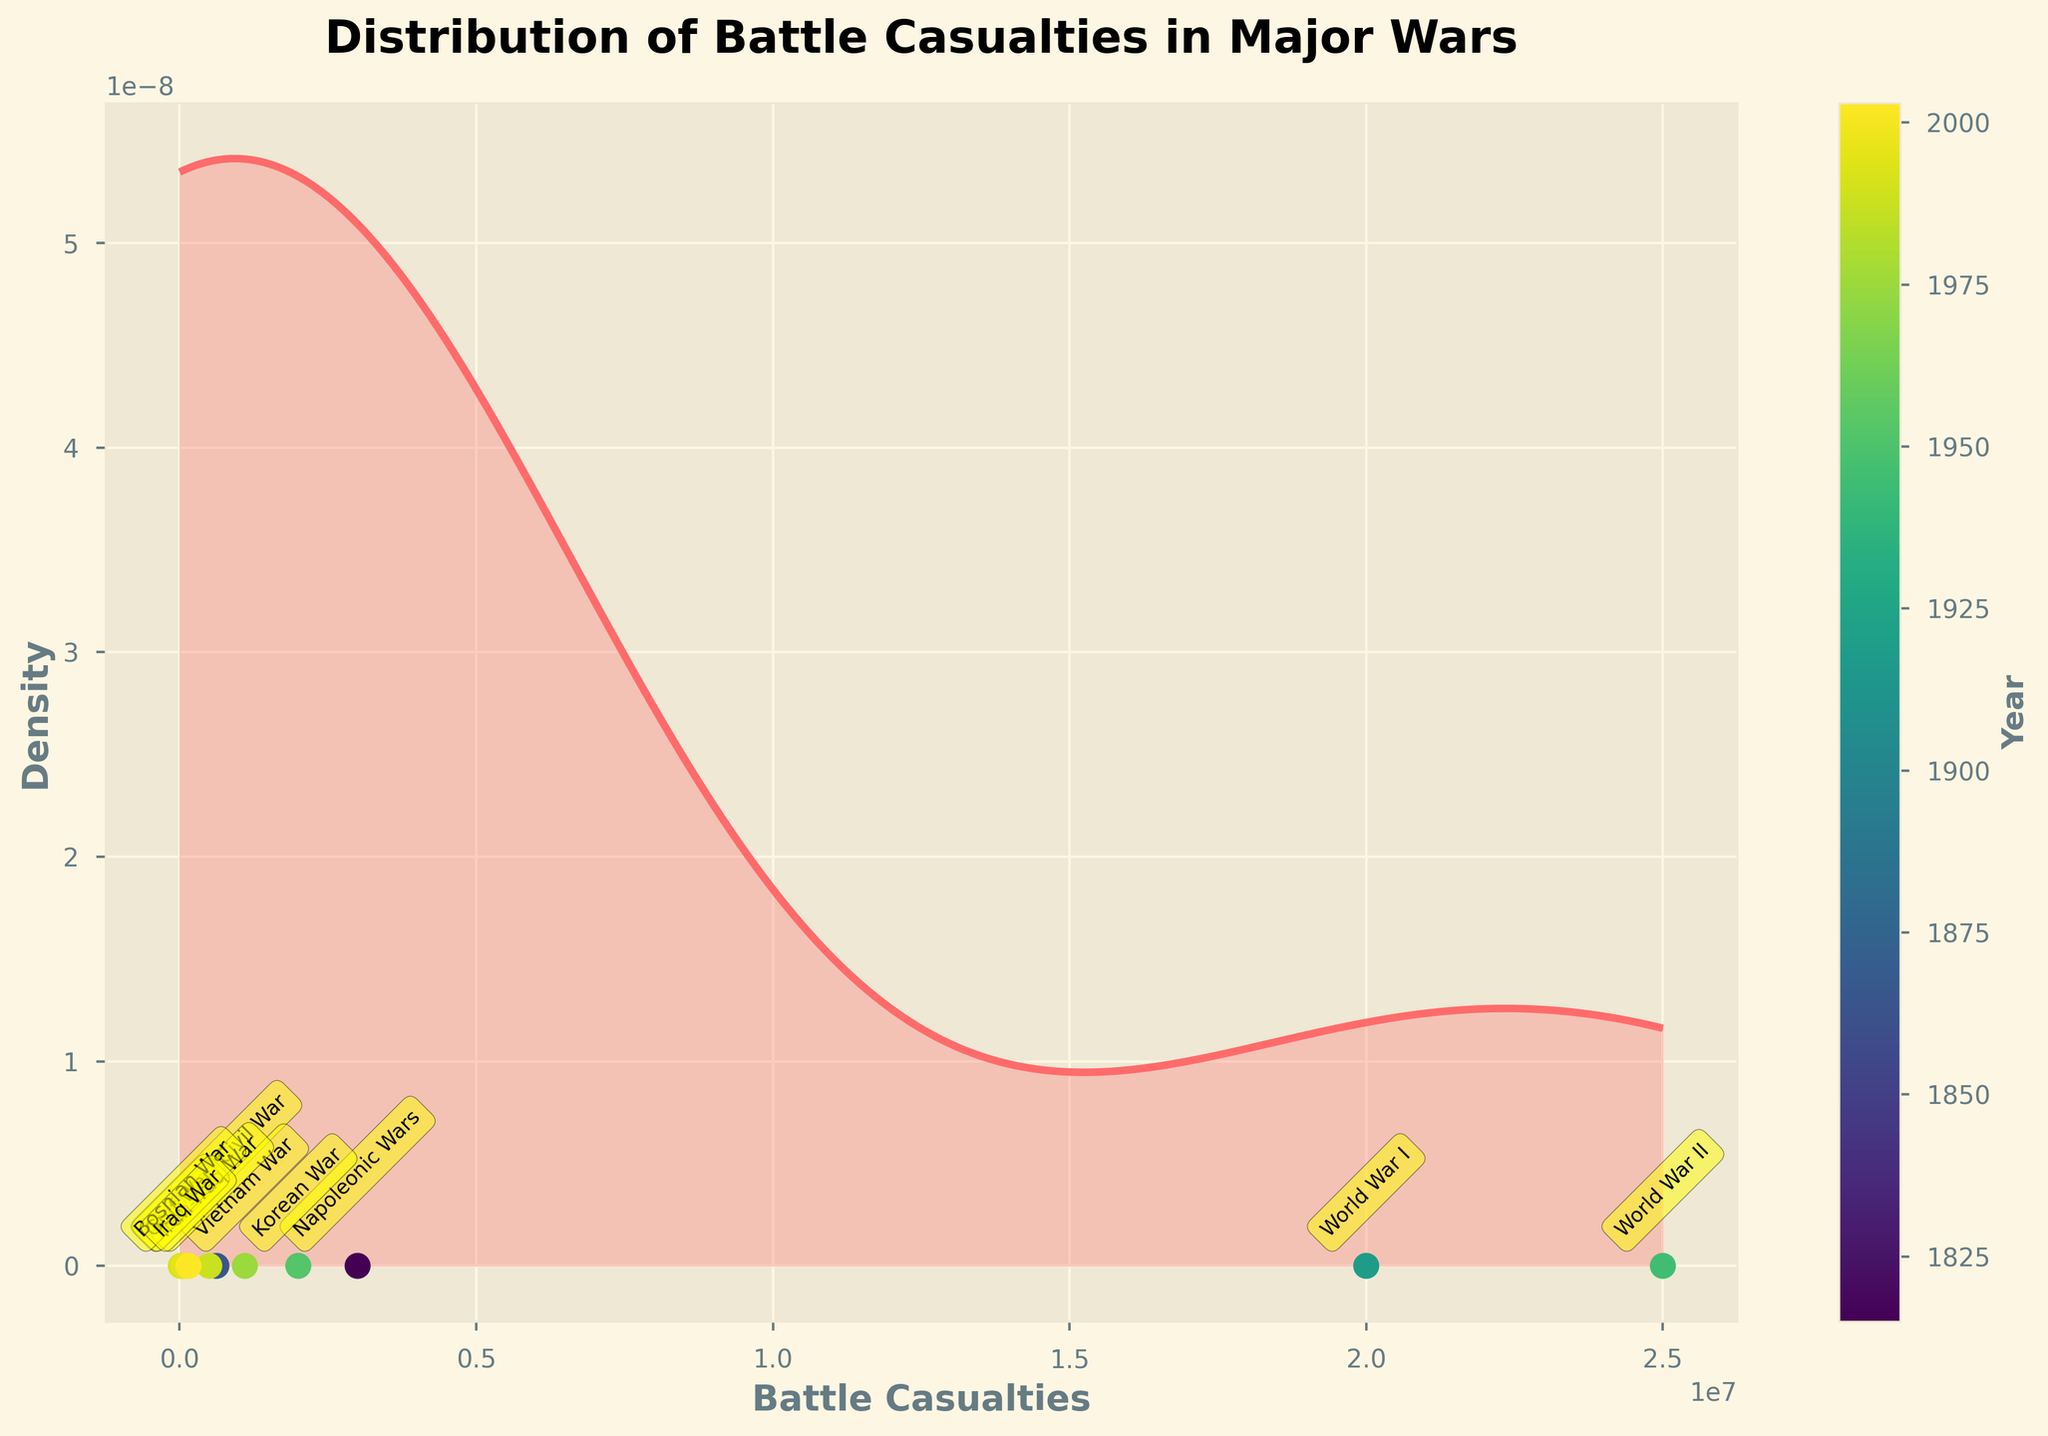What is the title of the plot? The title is usually located at the top of the plot. In this case, it reads "Distribution of Battle Casualties in Major Wars".
Answer: Distribution of Battle Casualties in Major Wars What are the axes labels of the plot? The x-axis label is "Battle Casualties" and the y-axis label is "Density". These are found below the x-axis and to the left of the y-axis, respectively.
Answer: Battle Casualties and Density Which war had the highest number of battle casualties? Based on the annotated points on the scatter plot, World War II had the highest number of battle casualties, indicated at the far right.
Answer: World War II What do the colors of the scatter points represent? The scatter points are color-coded according to the year of each war. This is indicated by the colorbar labeled 'Year' on the right side of the plot.
Answer: Year Between which years do the wars represented in the plot occur? The scatter points correspond to wars ranging from 1815 to 2003, as indicated by the years provided in the data and represented on the scatter points.
Answer: 1815 to 2003 How does the density of battle casualties vary with the number of casualties? The curve shows higher density at lower casualty numbers, indicating most wars had relatively fewer battle casualties, with density dropping off as casualties increase. This can be seen by the higher peaks of the plot towards the lower values on the x-axis.
Answer: Higher density at lower casualties Which war has the lowest number of battle casualties in the plot? The scatter point with the lowest battle casualties on the plot corresponds to the Gulf War.
Answer: Gulf War How do the battle casualties of the American Civil War compare to the Vietnam War? According to the scatter points, the American Civil War had fewer battle casualties (620,000) compared to the Vietnam War (1,100,000), as shown by their respective positions along the x-axis.
Answer: Fewer Among the recorded wars, which ones have battle casualties above 1,000,000 but below 2,000,000? According to the scatter points, World War I and Korean War fall within this range of battle casualties.
Answer: World War I and Korean War What is the purpose of using a Gaussian kernel density estimate (KDE) in this plot? KDE helps to visualize the distribution of battle casualties without being overly influenced by specific values and provides a smoothed density representation to infer overall trends.
Answer: Visualize the distribution of battle casualties 